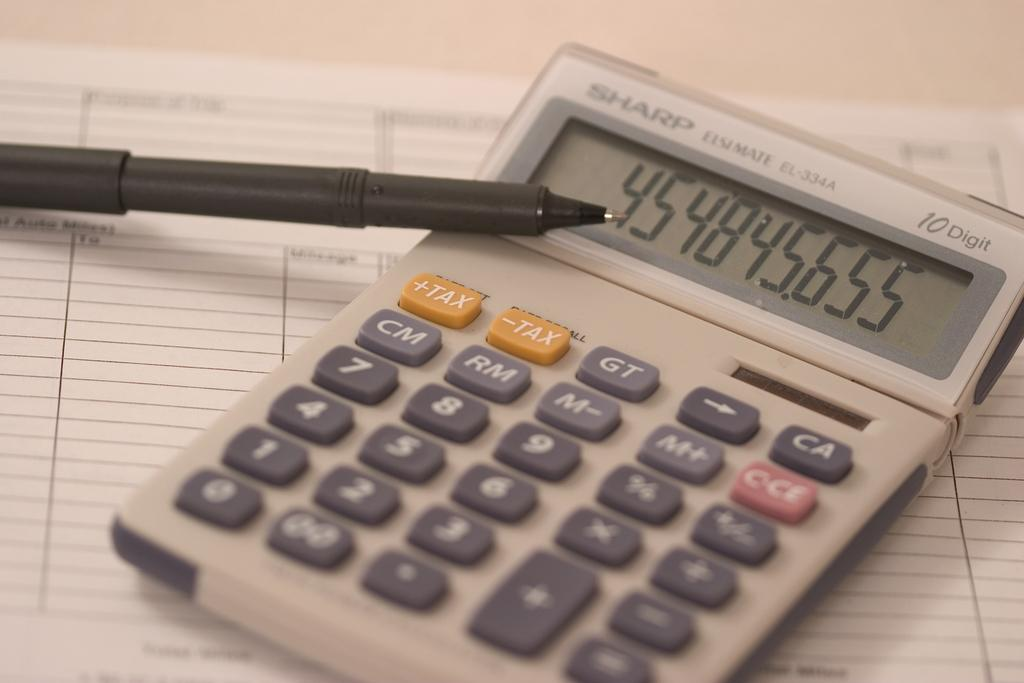<image>
Give a short and clear explanation of the subsequent image. An old Sharp desktop calculator is on top of a sheet of tables. 